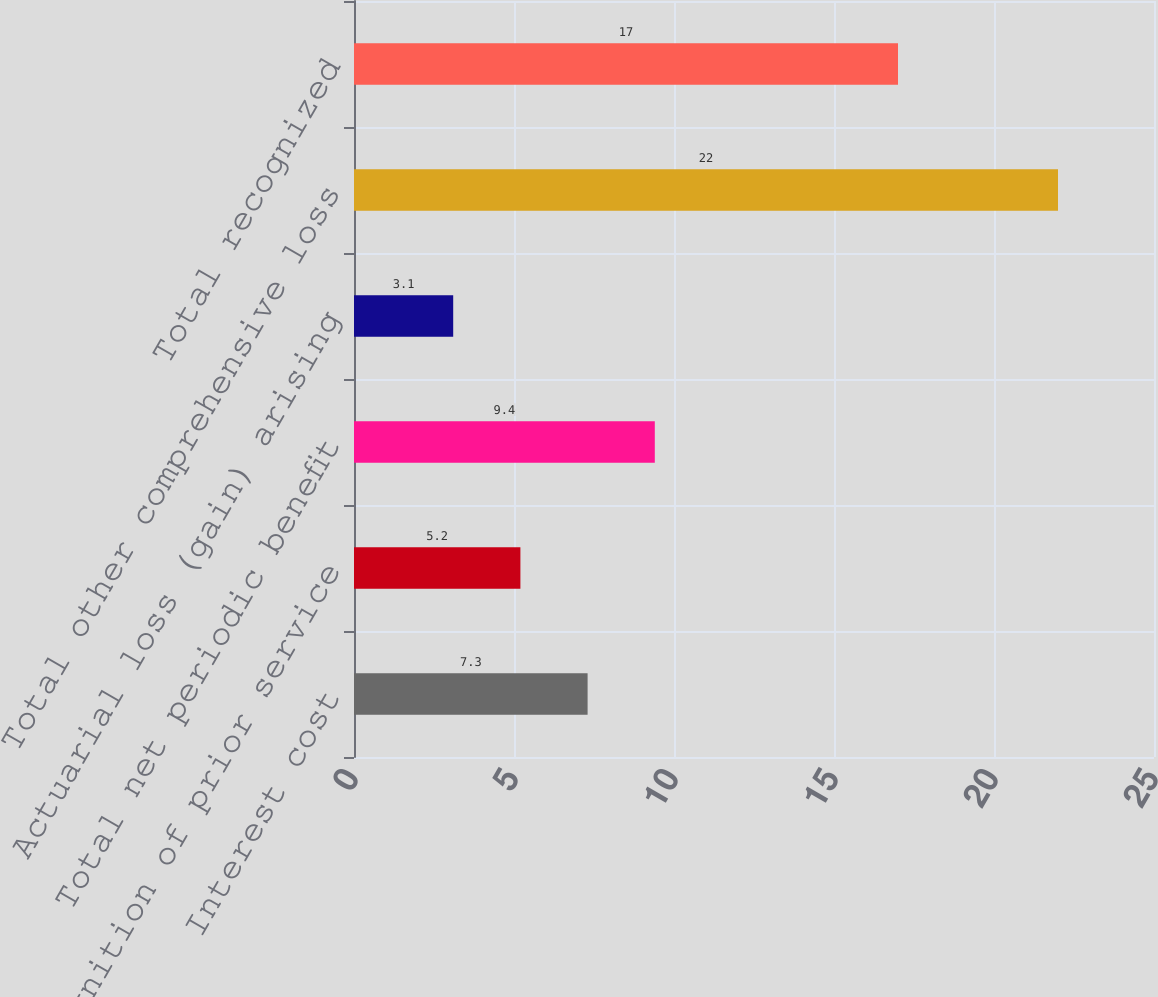Convert chart. <chart><loc_0><loc_0><loc_500><loc_500><bar_chart><fcel>Interest cost<fcel>Recognition of prior service<fcel>Total net periodic benefit<fcel>Actuarial loss (gain) arising<fcel>Total other comprehensive loss<fcel>Total recognized<nl><fcel>7.3<fcel>5.2<fcel>9.4<fcel>3.1<fcel>22<fcel>17<nl></chart> 